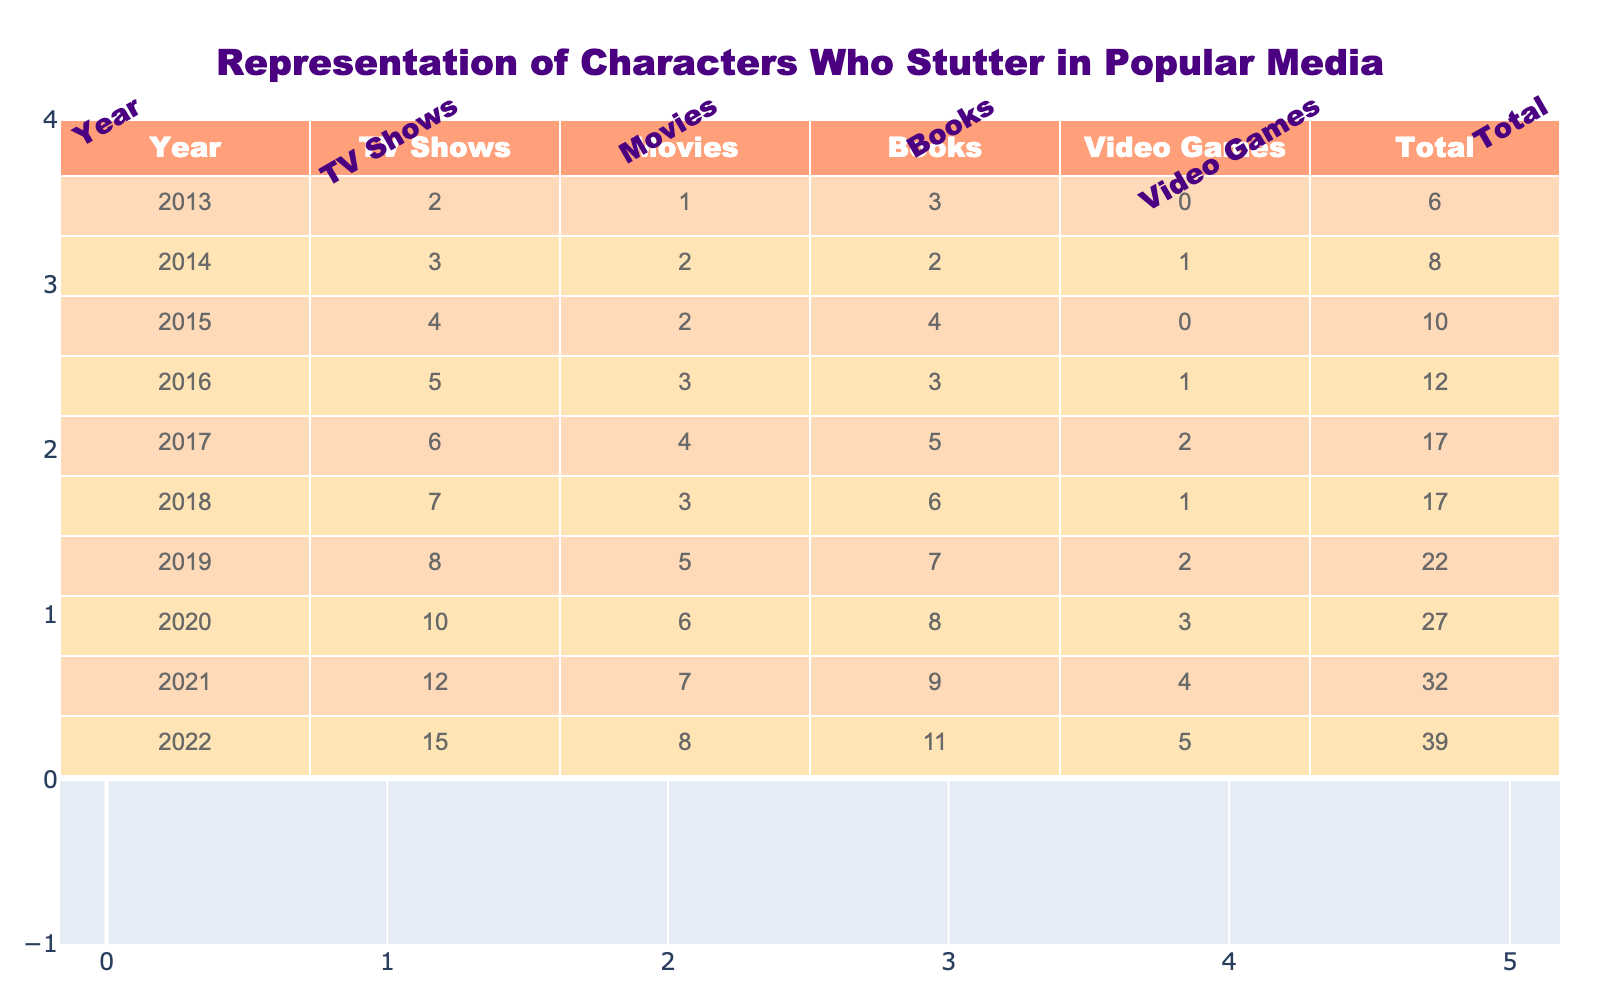What was the total representation of characters who stutter in 2018? In 2018, the total number of representations of characters who stutter across all media types is given in the table under the column "Total", which shows a value of 17.
Answer: 17 Which year had the highest increase in representations compared to the previous year? To determine the year with the highest increase, we can look at the "Total" column and calculate the difference between each consecutive year. The year 2021 had an increase of 5 (from 27 in 2020 to 32 in 2021), which is the largest increase from any previous year.
Answer: 2021 How many more movies featured characters who stutter in 2022 compared to 2013? We take the number of movies from 2022, which is 8, and subtract the number of movies from 2013, which is 1. So, 8 - 1 = 7.
Answer: 7 What is the average number of TV shows featuring characters who stutter from 2013 to 2022? To find the average, we sum the number of TV shows over the years: (2 + 3 + 4 + 5 + 6 + 7 + 8 + 10 + 12 + 15) = 72. There are 10 years, so we divide 72 by 10, resulting in 7.2.
Answer: 7.2 Is it true that the total representation of characters who stutter in 2020 was less than in 2019? Looking at the total values, in 2020 the total was 27, while in 2019 it was 22. Therefore, it is false that the 2020 total was less than 2019.
Answer: False What was the total representation of characters who stutter in movies from 2015 to 2020? The total representation in movies over these years can be found by adding the values: 2 (2015) + 2 (2016) + 3 (2017) + 5 (2018) + 6 (2019) + 6 (2020) = 24.
Answer: 24 Which media type had the least representation in 2013? By reviewing the data for 2013, the Video Games column shows a value of 0, indicating that there were no representations of characters who stutter in video games that year.
Answer: Video Games What was the trend in the number of video games featuring characters who stutter from 2013 to 2022? The table shows an increase in video games over these years, with 0 in 2013 and increasing to 5 in 2022. This indicates a growing trend of representation in video games.
Answer: Increasing What is the total representation of characters who stutter across all media types over the last decade? To find the total representation over the decade, we sum the last year in the Total column, which is 39 for 2022.
Answer: 39 In which year was there a higher representation of characters in books than in movies? By examining the table, in 2015 (books=4, movies=2), 2016 (books=3, movies=3), and 2017 (books=5, movies=4), we notice these are the years when book representation exceeded movie representation.
Answer: 2015, 2016, 2017 